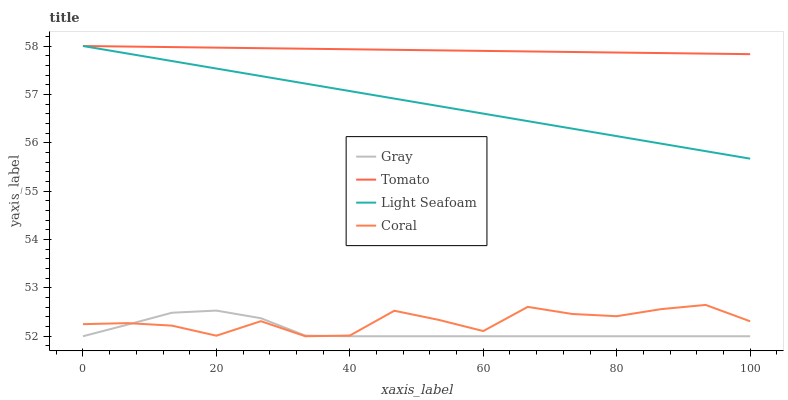Does Gray have the minimum area under the curve?
Answer yes or no. Yes. Does Tomato have the maximum area under the curve?
Answer yes or no. Yes. Does Coral have the minimum area under the curve?
Answer yes or no. No. Does Coral have the maximum area under the curve?
Answer yes or no. No. Is Tomato the smoothest?
Answer yes or no. Yes. Is Coral the roughest?
Answer yes or no. Yes. Is Gray the smoothest?
Answer yes or no. No. Is Gray the roughest?
Answer yes or no. No. Does Gray have the lowest value?
Answer yes or no. Yes. Does Light Seafoam have the lowest value?
Answer yes or no. No. Does Light Seafoam have the highest value?
Answer yes or no. Yes. Does Coral have the highest value?
Answer yes or no. No. Is Coral less than Light Seafoam?
Answer yes or no. Yes. Is Tomato greater than Gray?
Answer yes or no. Yes. Does Light Seafoam intersect Tomato?
Answer yes or no. Yes. Is Light Seafoam less than Tomato?
Answer yes or no. No. Is Light Seafoam greater than Tomato?
Answer yes or no. No. Does Coral intersect Light Seafoam?
Answer yes or no. No. 